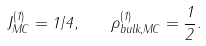<formula> <loc_0><loc_0><loc_500><loc_500>J _ { M C } ^ { ( 1 ) } = 1 / 4 , \quad \rho _ { b u l k , M C } ^ { ( 1 ) } = \frac { 1 } { 2 } .</formula> 